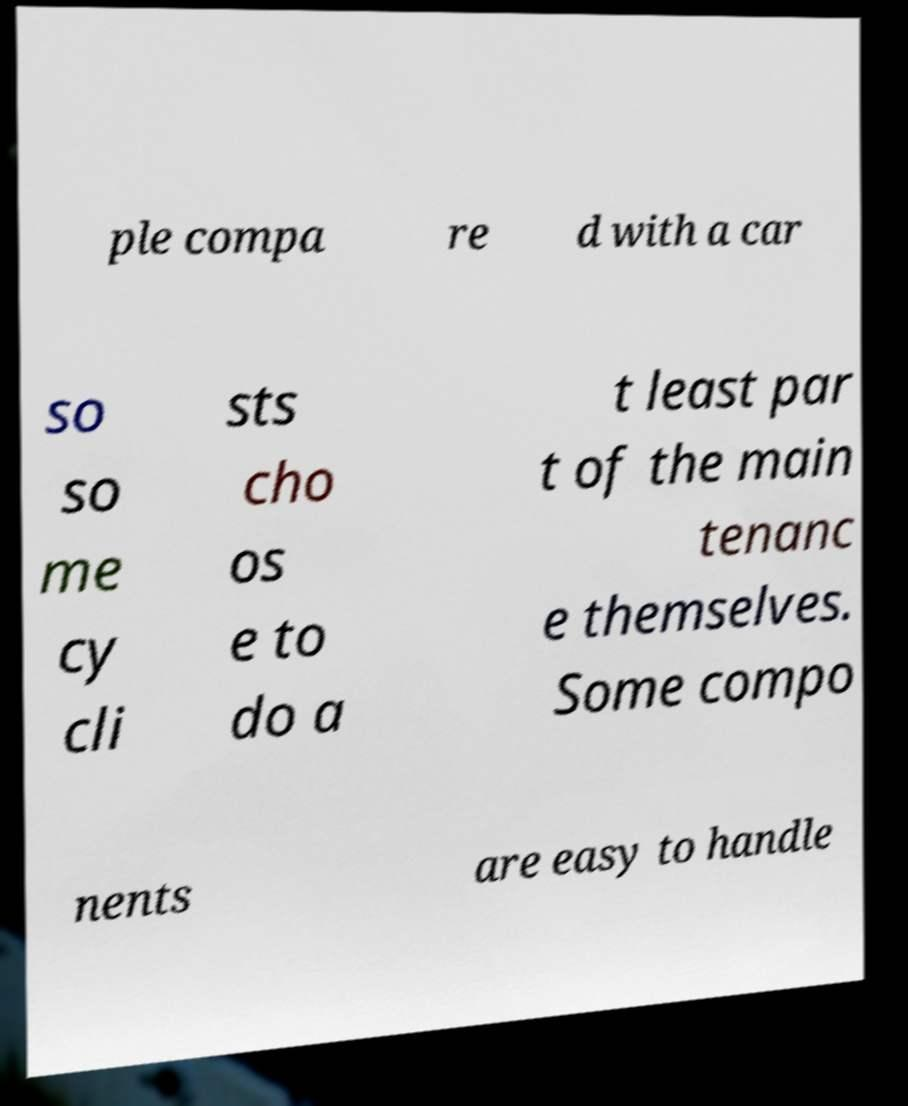What messages or text are displayed in this image? I need them in a readable, typed format. ple compa re d with a car so so me cy cli sts cho os e to do a t least par t of the main tenanc e themselves. Some compo nents are easy to handle 